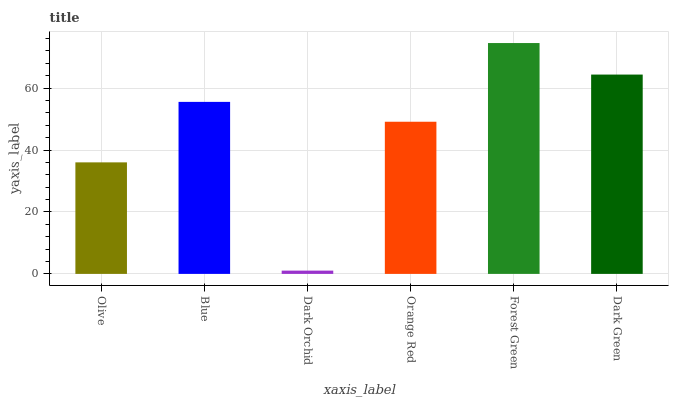Is Dark Orchid the minimum?
Answer yes or no. Yes. Is Forest Green the maximum?
Answer yes or no. Yes. Is Blue the minimum?
Answer yes or no. No. Is Blue the maximum?
Answer yes or no. No. Is Blue greater than Olive?
Answer yes or no. Yes. Is Olive less than Blue?
Answer yes or no. Yes. Is Olive greater than Blue?
Answer yes or no. No. Is Blue less than Olive?
Answer yes or no. No. Is Blue the high median?
Answer yes or no. Yes. Is Orange Red the low median?
Answer yes or no. Yes. Is Dark Green the high median?
Answer yes or no. No. Is Blue the low median?
Answer yes or no. No. 